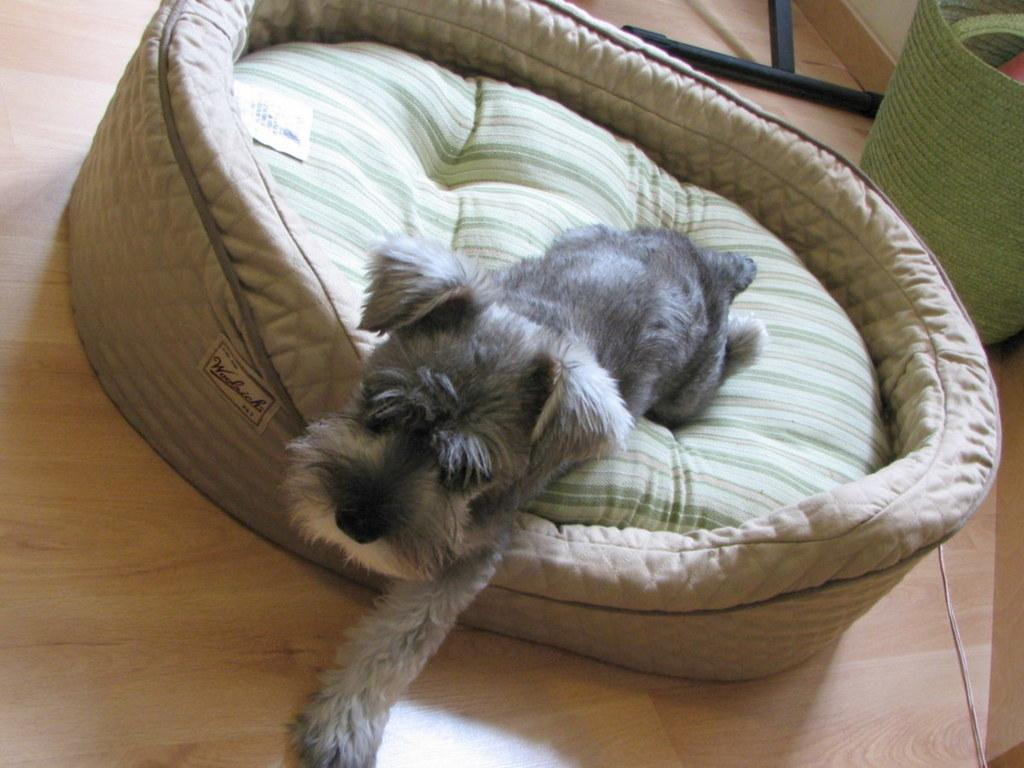What type of animal is in the image? There is a dog in the image. What colors can be seen on the dog? The dog is gray and white in color. Where is the dog located in the image? The dog is on a bed. What color is the bed? The bed is cream-colored. What can be seen in the background of the image? The background of the image includes a green mat. What color is the floor in the image? The floor is cream-colored. What type of work does the dog achieve in the image? The dog is not performing any work in the image; it is simply lying on a bed. Can you see an arch in the image? There is no arch present in the image. 